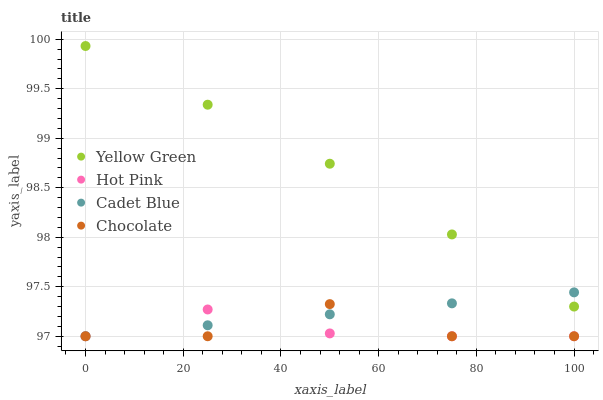Does Hot Pink have the minimum area under the curve?
Answer yes or no. Yes. Does Yellow Green have the maximum area under the curve?
Answer yes or no. Yes. Does Yellow Green have the minimum area under the curve?
Answer yes or no. No. Does Hot Pink have the maximum area under the curve?
Answer yes or no. No. Is Cadet Blue the smoothest?
Answer yes or no. Yes. Is Chocolate the roughest?
Answer yes or no. Yes. Is Hot Pink the smoothest?
Answer yes or no. No. Is Hot Pink the roughest?
Answer yes or no. No. Does Cadet Blue have the lowest value?
Answer yes or no. Yes. Does Yellow Green have the lowest value?
Answer yes or no. No. Does Yellow Green have the highest value?
Answer yes or no. Yes. Does Hot Pink have the highest value?
Answer yes or no. No. Is Chocolate less than Yellow Green?
Answer yes or no. Yes. Is Yellow Green greater than Chocolate?
Answer yes or no. Yes. Does Hot Pink intersect Cadet Blue?
Answer yes or no. Yes. Is Hot Pink less than Cadet Blue?
Answer yes or no. No. Is Hot Pink greater than Cadet Blue?
Answer yes or no. No. Does Chocolate intersect Yellow Green?
Answer yes or no. No. 